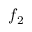Convert formula to latex. <formula><loc_0><loc_0><loc_500><loc_500>f _ { 2 }</formula> 